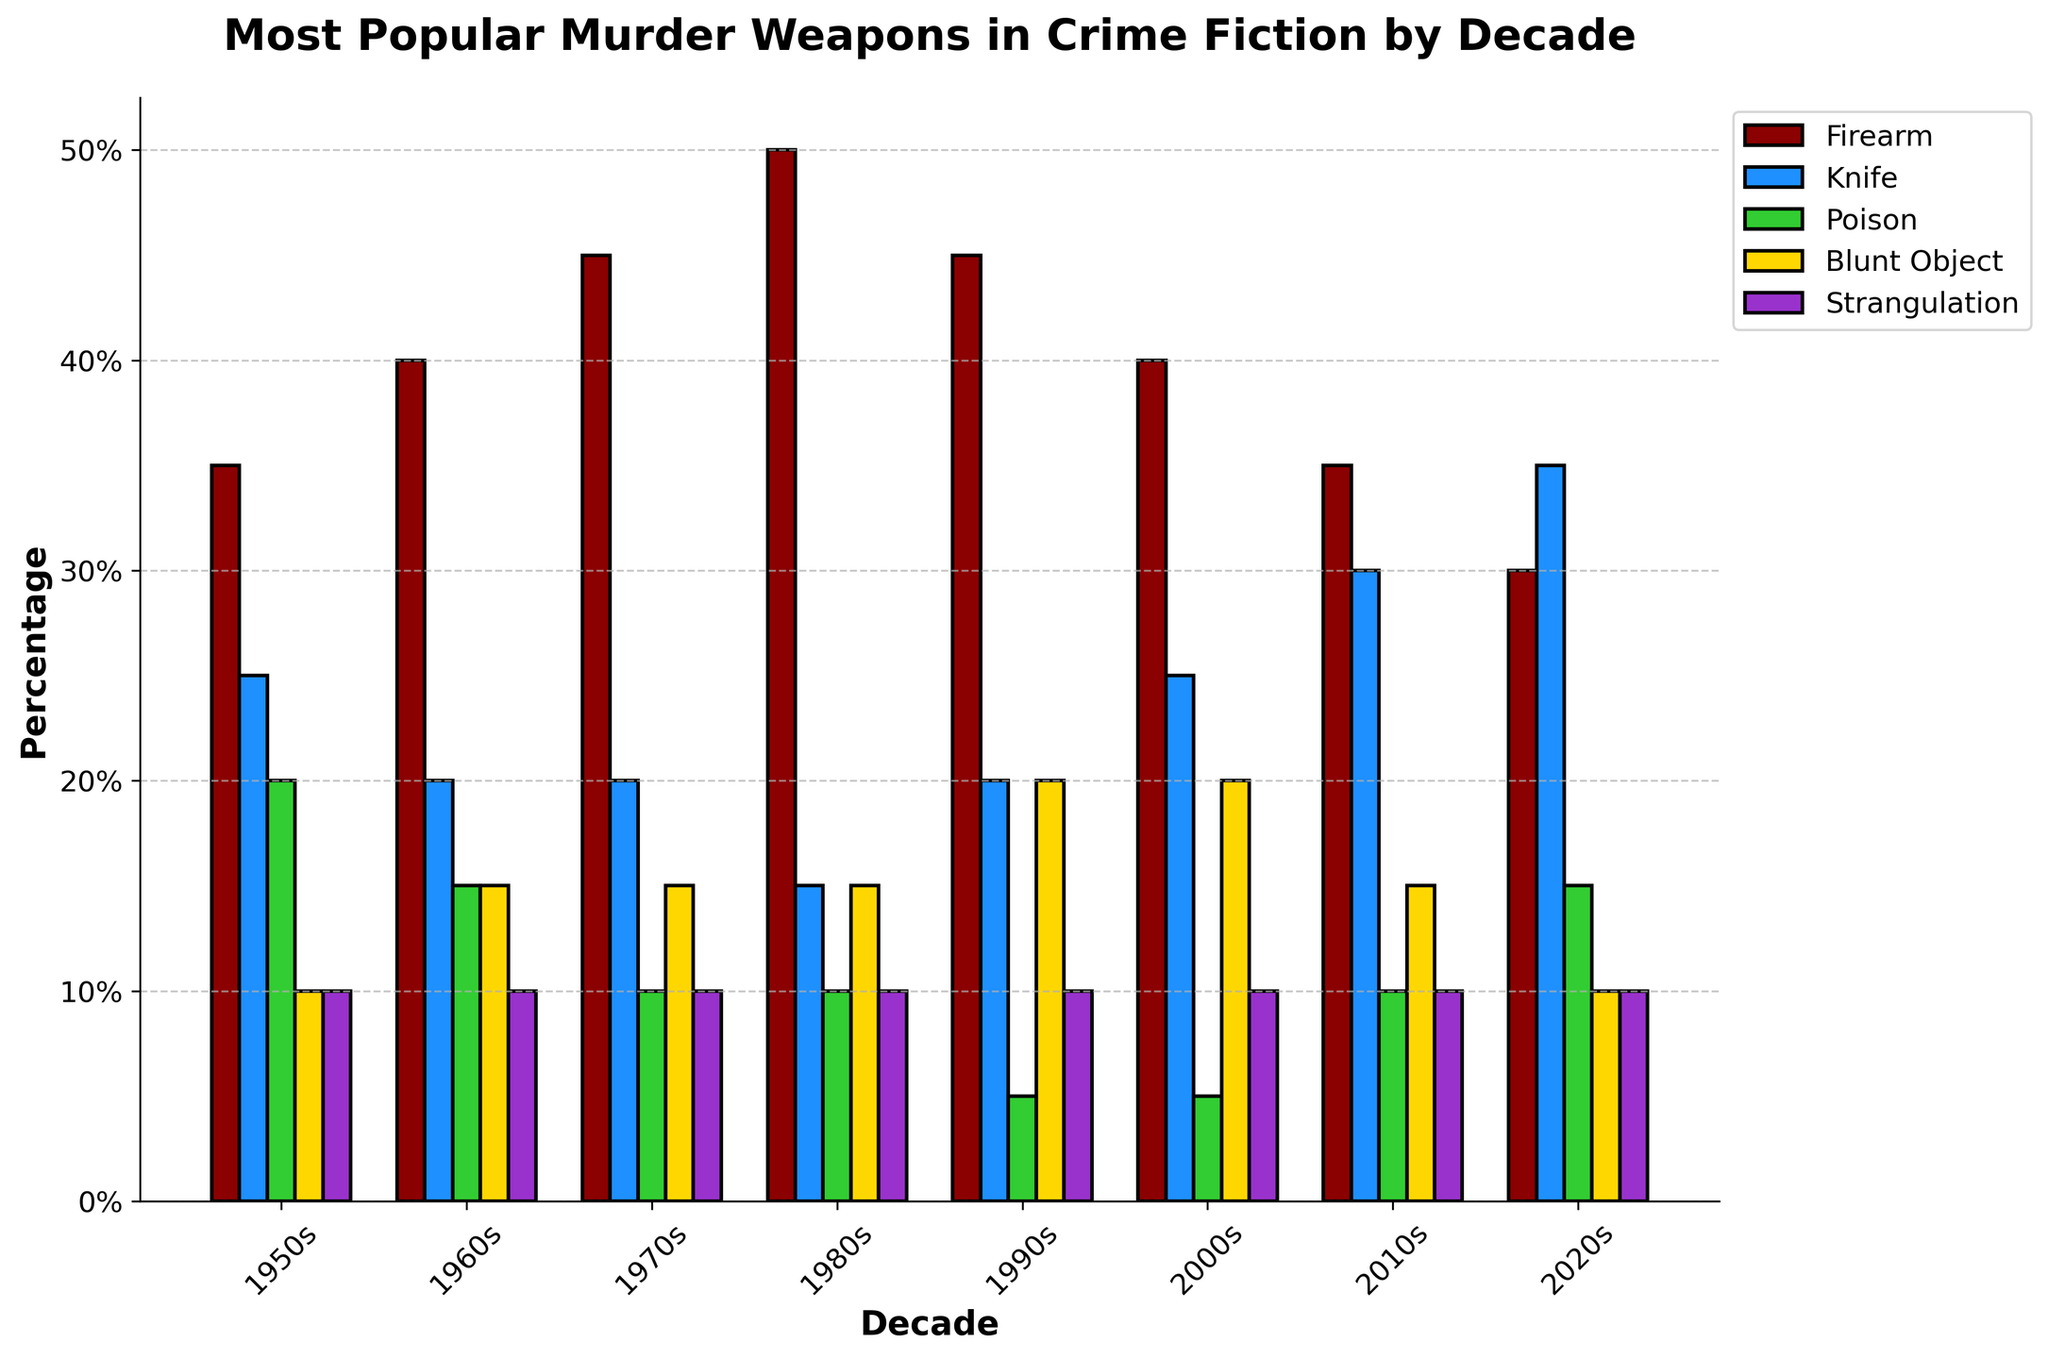Which decade had the highest popularity of firearms as murder weapons? Observe the bar heights associated with the "Firearm" weapon category across all decades. The 1980s has the highest bar, indicating the highest popularity.
Answer: 1980s Between poison and blunt objects, which weapon category saw a resurgence in the 2000s? Compare the bar heights for "Poison" and "Blunt Object" in the 2000s to previous decades. Blunt Object shows an increase in height compared to the 1990s, while Poison remains relatively low and consistent.
Answer: Blunt Object What is the combined percentage of knife and firearm use in the 2020s? Add the heights of the bars representing "Knife" and "Firearm" for the 2020s. Knife is at 35%, and Firearm is at 30%, summing to 65%.
Answer: 65% Which weapon saw consistent usage throughout all decades without significant increase or decrease? Look for a weapon category where the bar heights do not vary significantly across decades. Strangulation remains flat at 10% throughout all decades.
Answer: Strangulation How does the popularity of knives in the 2010s compare to the 1950s and 1960s? Observe and compare the bar heights for "Knife" in the 2010s (30%), 1950s (25%), and 1960s (20%). The 2010s show an increase compared to both the 1950s and 1960s.
Answer: Increased Which weapon category had the lowest popularity in the 1990s? Identify the shortest bar in the 1990s section. Poison, at 5%, is the lowest.
Answer: Poison What is the average usage percentage of blunt objects over all decades? Sum the bar heights for "Blunt Object" across all decades (10 + 15 + 15 + 15 + 20 + 20 + 15 + 10 = 120) and divide by the number of decades (8). The average is 120/8 = 15%.
Answer: 15% How did the usage of poison change from the 1950s to the 2020s? Observe and compare the bar heights for "Poison" in the 1950s (20%) and the 2020s (15%). Poison usage decreased from 20% to 15%.
Answer: Decreased In which decade did all weapon categories (firearm, knife, poison, blunt object, strangulation) have non-zero usage? Check each decade to see if all bars have a non-zero height. All decades show non-zero usage in all categories.
Answer: All decades Which weapon had the highest increase in popularity from the 2000s to the 2020s? Compare the percentage changes for all weapon categories between the 2000s and 2020s. The knife category shows the most significant increase, from 25% to 35%, an increase of 10%.
Answer: Knife 